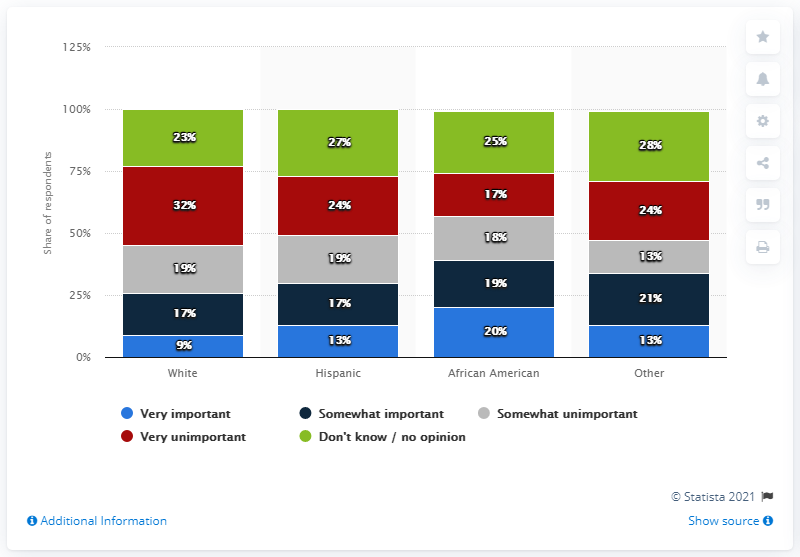Outline some significant characteristics in this image. According to a survey, 13% of Hispanics believed it was crucial for Biden to select a running mate who is a person of color. Out of the respondents who identified as Hispanic, 13% believed that it was very important. The total number of individuals who hold no opinion is 103. 